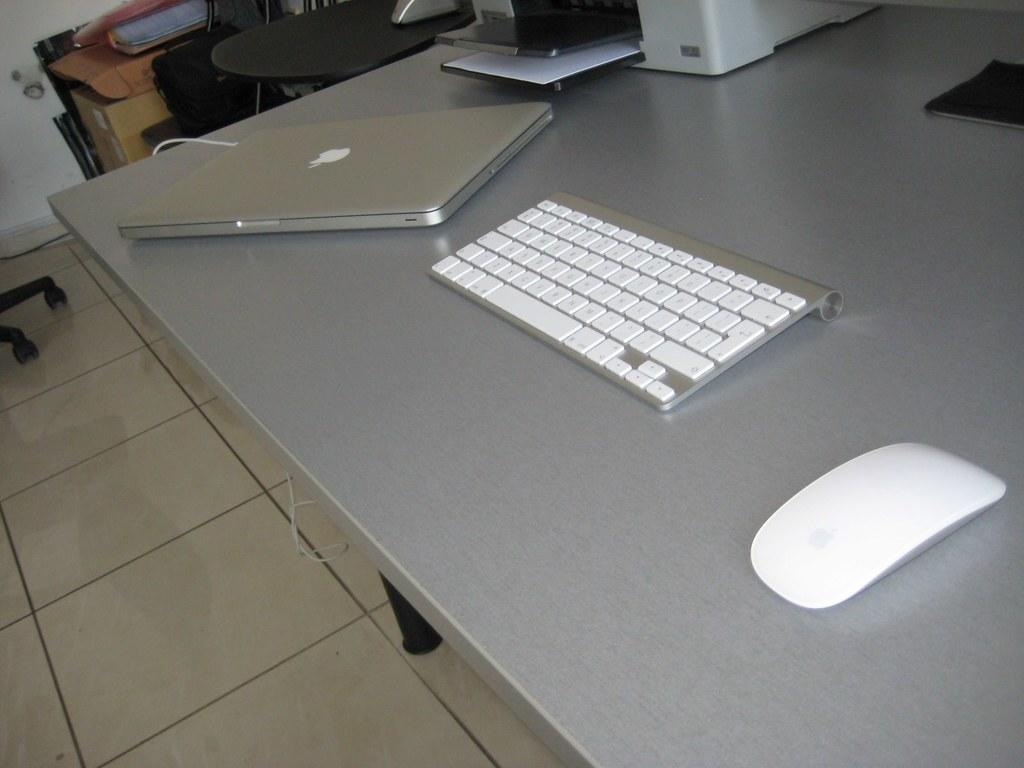What electronic device is on the table in the image? There is a laptop on the table in the image. What other computer accessories are on the table? There is a keyboard and a mouse on the table. What device for printing documents is on the table? There is a printer on the table. What can be seen in the background of the image? In the background, there are tables and chairs. What type of chalk is being used to write on the laptop screen in the image? There is no chalk or writing on the laptop screen in the image. How does the person in the image react to the printer malfunctioning? There is no person visible in the image, so it is impossible to determine their reaction to the printer. 